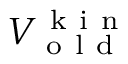Convert formula to latex. <formula><loc_0><loc_0><loc_500><loc_500>V _ { o l d } ^ { k i n }</formula> 